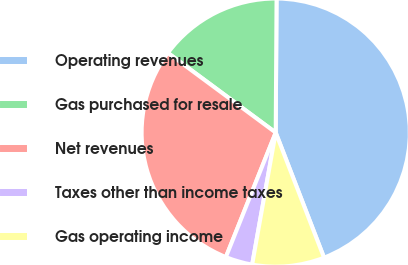Convert chart to OTSL. <chart><loc_0><loc_0><loc_500><loc_500><pie_chart><fcel>Operating revenues<fcel>Gas purchased for resale<fcel>Net revenues<fcel>Taxes other than income taxes<fcel>Gas operating income<nl><fcel>44.03%<fcel>14.97%<fcel>29.07%<fcel>3.25%<fcel>8.68%<nl></chart> 